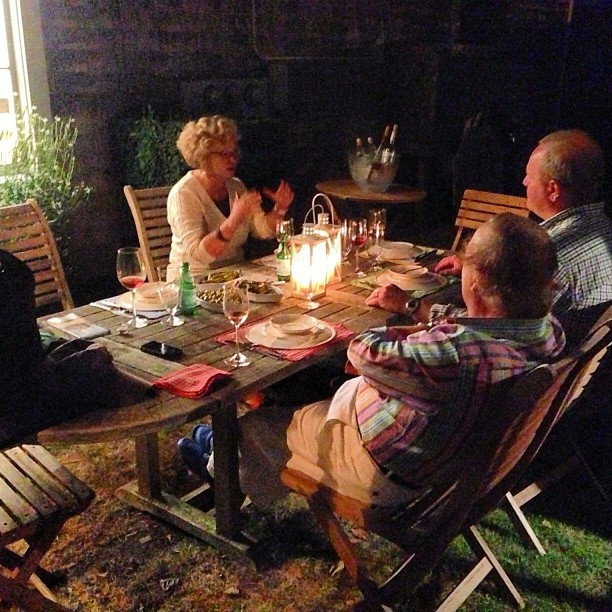Describe the objects in this image and their specific colors. I can see people in white, black, maroon, tan, and brown tones, dining table in white, gray, maroon, black, and tan tones, chair in white, black, maroon, and gray tones, people in white, black, gray, maroon, and darkgray tones, and people in white, maroon, brown, tan, and salmon tones in this image. 